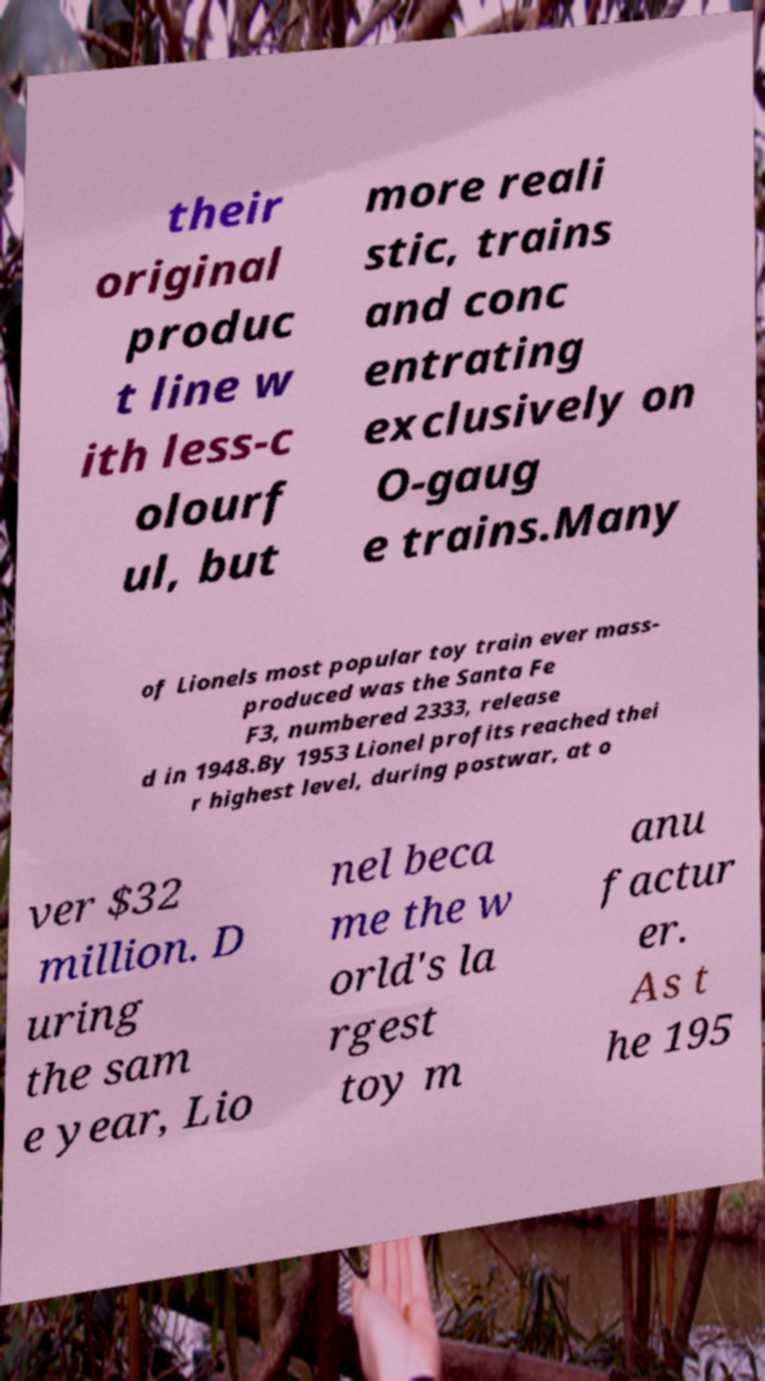For documentation purposes, I need the text within this image transcribed. Could you provide that? their original produc t line w ith less-c olourf ul, but more reali stic, trains and conc entrating exclusively on O-gaug e trains.Many of Lionels most popular toy train ever mass- produced was the Santa Fe F3, numbered 2333, release d in 1948.By 1953 Lionel profits reached thei r highest level, during postwar, at o ver $32 million. D uring the sam e year, Lio nel beca me the w orld's la rgest toy m anu factur er. As t he 195 